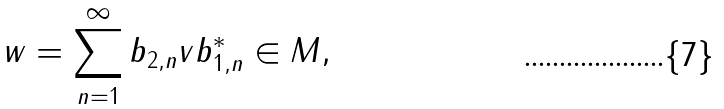<formula> <loc_0><loc_0><loc_500><loc_500>w = \sum _ { n = 1 } ^ { \infty } b _ { 2 , n } v b _ { 1 , n } ^ { * } \in M ,</formula> 